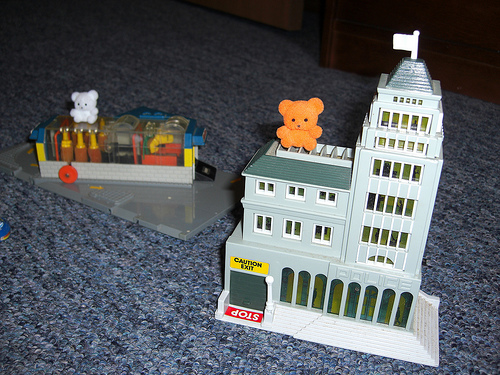<image>
Is the brown bear on the roof? Yes. Looking at the image, I can see the brown bear is positioned on top of the roof, with the roof providing support. 